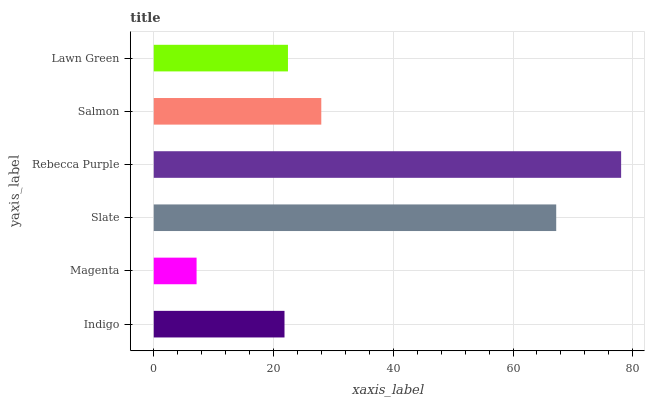Is Magenta the minimum?
Answer yes or no. Yes. Is Rebecca Purple the maximum?
Answer yes or no. Yes. Is Slate the minimum?
Answer yes or no. No. Is Slate the maximum?
Answer yes or no. No. Is Slate greater than Magenta?
Answer yes or no. Yes. Is Magenta less than Slate?
Answer yes or no. Yes. Is Magenta greater than Slate?
Answer yes or no. No. Is Slate less than Magenta?
Answer yes or no. No. Is Salmon the high median?
Answer yes or no. Yes. Is Lawn Green the low median?
Answer yes or no. Yes. Is Rebecca Purple the high median?
Answer yes or no. No. Is Indigo the low median?
Answer yes or no. No. 